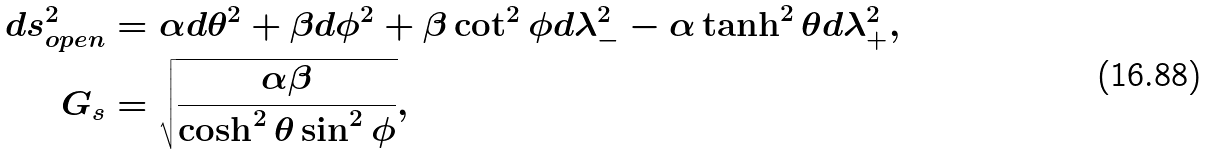<formula> <loc_0><loc_0><loc_500><loc_500>d s _ { o p e n } ^ { 2 } & = \alpha d \theta ^ { 2 } + \beta d \phi ^ { 2 } + \beta \cot ^ { 2 } \phi d \lambda _ { - } ^ { 2 } - \alpha \tanh ^ { 2 } \theta d \lambda _ { + } ^ { 2 } , \\ G _ { s } & = \sqrt { \frac { \alpha \beta } { \cosh ^ { 2 } \theta \sin ^ { 2 } \phi } } ,</formula> 